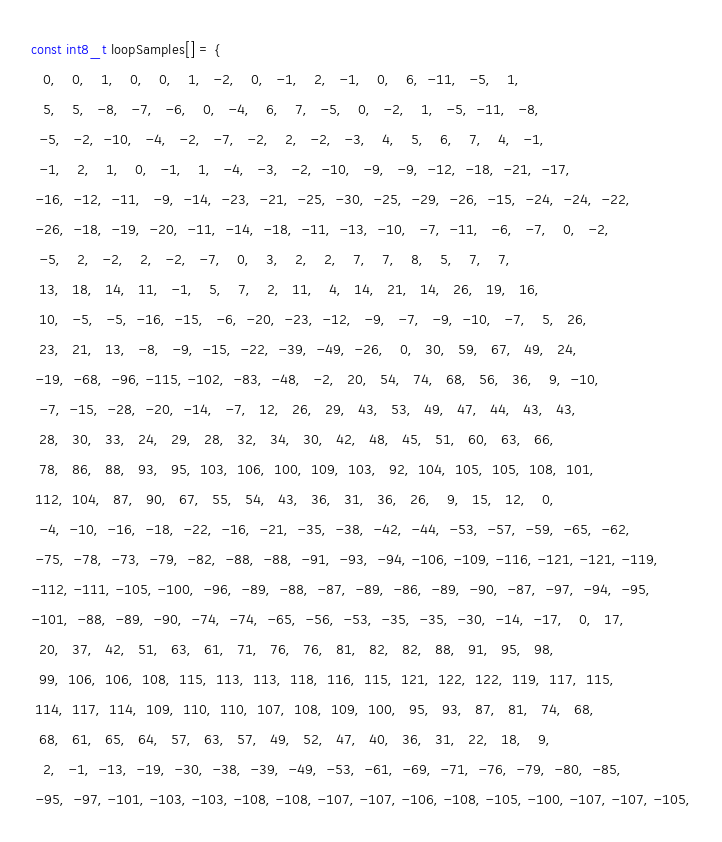Convert code to text. <code><loc_0><loc_0><loc_500><loc_500><_C_>const int8_t loopSamples[] = {
   0,    0,    1,    0,    0,    1,   -2,    0,   -1,    2,   -1,    0,    6,  -11,   -5,    1,
   5,    5,   -8,   -7,   -6,    0,   -4,    6,    7,   -5,    0,   -2,    1,   -5,  -11,   -8,
  -5,   -2,  -10,   -4,   -2,   -7,   -2,    2,   -2,   -3,    4,    5,    6,    7,    4,   -1,
  -1,    2,    1,    0,   -1,    1,   -4,   -3,   -2,  -10,   -9,   -9,  -12,  -18,  -21,  -17,
 -16,  -12,  -11,   -9,  -14,  -23,  -21,  -25,  -30,  -25,  -29,  -26,  -15,  -24,  -24,  -22,
 -26,  -18,  -19,  -20,  -11,  -14,  -18,  -11,  -13,  -10,   -7,  -11,   -6,   -7,    0,   -2,
  -5,    2,   -2,    2,   -2,   -7,    0,    3,    2,    2,    7,    7,    8,    5,    7,    7,
  13,   18,   14,   11,   -1,    5,    7,    2,   11,    4,   14,   21,   14,   26,   19,   16,
  10,   -5,   -5,  -16,  -15,   -6,  -20,  -23,  -12,   -9,   -7,   -9,  -10,   -7,    5,   26,
  23,   21,   13,   -8,   -9,  -15,  -22,  -39,  -49,  -26,    0,   30,   59,   67,   49,   24,
 -19,  -68,  -96, -115, -102,  -83,  -48,   -2,   20,   54,   74,   68,   56,   36,    9,  -10,
  -7,  -15,  -28,  -20,  -14,   -7,   12,   26,   29,   43,   53,   49,   47,   44,   43,   43,
  28,   30,   33,   24,   29,   28,   32,   34,   30,   42,   48,   45,   51,   60,   63,   66,
  78,   86,   88,   93,   95,  103,  106,  100,  109,  103,   92,  104,  105,  105,  108,  101,
 112,  104,   87,   90,   67,   55,   54,   43,   36,   31,   36,   26,    9,   15,   12,    0,
  -4,  -10,  -16,  -18,  -22,  -16,  -21,  -35,  -38,  -42,  -44,  -53,  -57,  -59,  -65,  -62,
 -75,  -78,  -73,  -79,  -82,  -88,  -88,  -91,  -93,  -94, -106, -109, -116, -121, -121, -119,
-112, -111, -105, -100,  -96,  -89,  -88,  -87,  -89,  -86,  -89,  -90,  -87,  -97,  -94,  -95,
-101,  -88,  -89,  -90,  -74,  -74,  -65,  -56,  -53,  -35,  -35,  -30,  -14,  -17,    0,   17,
  20,   37,   42,   51,   63,   61,   71,   76,   76,   81,   82,   82,   88,   91,   95,   98,
  99,  106,  106,  108,  115,  113,  113,  118,  116,  115,  121,  122,  122,  119,  117,  115,
 114,  117,  114,  109,  110,  110,  107,  108,  109,  100,   95,   93,   87,   81,   74,   68,
  68,   61,   65,   64,   57,   63,   57,   49,   52,   47,   40,   36,   31,   22,   18,    9,
   2,   -1,  -13,  -19,  -30,  -38,  -39,  -49,  -53,  -61,  -69,  -71,  -76,  -79,  -80,  -85,
 -95,  -97, -101, -103, -103, -108, -108, -107, -107, -106, -108, -105, -100, -107, -107, -105,</code> 